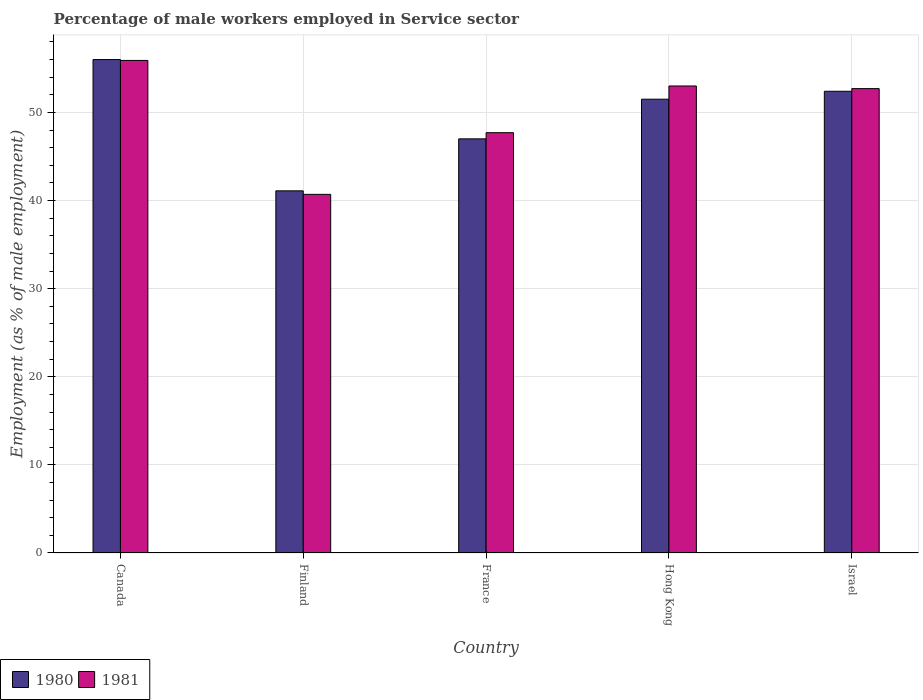How many different coloured bars are there?
Provide a succinct answer. 2. How many groups of bars are there?
Ensure brevity in your answer.  5. What is the label of the 4th group of bars from the left?
Provide a succinct answer. Hong Kong. In how many cases, is the number of bars for a given country not equal to the number of legend labels?
Offer a terse response. 0. Across all countries, what is the maximum percentage of male workers employed in Service sector in 1980?
Your answer should be very brief. 56. Across all countries, what is the minimum percentage of male workers employed in Service sector in 1980?
Keep it short and to the point. 41.1. In which country was the percentage of male workers employed in Service sector in 1980 maximum?
Your answer should be very brief. Canada. In which country was the percentage of male workers employed in Service sector in 1981 minimum?
Your answer should be very brief. Finland. What is the total percentage of male workers employed in Service sector in 1980 in the graph?
Your response must be concise. 248. What is the difference between the percentage of male workers employed in Service sector in 1980 in Canada and that in Israel?
Provide a short and direct response. 3.6. What is the difference between the percentage of male workers employed in Service sector in 1981 in France and the percentage of male workers employed in Service sector in 1980 in Israel?
Your response must be concise. -4.7. What is the average percentage of male workers employed in Service sector in 1980 per country?
Make the answer very short. 49.6. What is the difference between the percentage of male workers employed in Service sector of/in 1981 and percentage of male workers employed in Service sector of/in 1980 in Canada?
Provide a succinct answer. -0.1. What is the ratio of the percentage of male workers employed in Service sector in 1981 in France to that in Israel?
Provide a succinct answer. 0.91. Is the difference between the percentage of male workers employed in Service sector in 1981 in Finland and Israel greater than the difference between the percentage of male workers employed in Service sector in 1980 in Finland and Israel?
Keep it short and to the point. No. What is the difference between the highest and the lowest percentage of male workers employed in Service sector in 1980?
Provide a short and direct response. 14.9. In how many countries, is the percentage of male workers employed in Service sector in 1981 greater than the average percentage of male workers employed in Service sector in 1981 taken over all countries?
Make the answer very short. 3. Is the sum of the percentage of male workers employed in Service sector in 1980 in Finland and Hong Kong greater than the maximum percentage of male workers employed in Service sector in 1981 across all countries?
Provide a succinct answer. Yes. What does the 2nd bar from the left in Canada represents?
Offer a very short reply. 1981. How many bars are there?
Offer a very short reply. 10. Are all the bars in the graph horizontal?
Your answer should be very brief. No. How many countries are there in the graph?
Provide a short and direct response. 5. Are the values on the major ticks of Y-axis written in scientific E-notation?
Your response must be concise. No. Does the graph contain grids?
Your response must be concise. Yes. Where does the legend appear in the graph?
Make the answer very short. Bottom left. What is the title of the graph?
Make the answer very short. Percentage of male workers employed in Service sector. Does "2007" appear as one of the legend labels in the graph?
Make the answer very short. No. What is the label or title of the Y-axis?
Make the answer very short. Employment (as % of male employment). What is the Employment (as % of male employment) in 1980 in Canada?
Your response must be concise. 56. What is the Employment (as % of male employment) of 1981 in Canada?
Provide a short and direct response. 55.9. What is the Employment (as % of male employment) in 1980 in Finland?
Make the answer very short. 41.1. What is the Employment (as % of male employment) of 1981 in Finland?
Make the answer very short. 40.7. What is the Employment (as % of male employment) in 1981 in France?
Keep it short and to the point. 47.7. What is the Employment (as % of male employment) of 1980 in Hong Kong?
Your response must be concise. 51.5. What is the Employment (as % of male employment) of 1981 in Hong Kong?
Your answer should be compact. 53. What is the Employment (as % of male employment) in 1980 in Israel?
Provide a succinct answer. 52.4. What is the Employment (as % of male employment) in 1981 in Israel?
Offer a very short reply. 52.7. Across all countries, what is the maximum Employment (as % of male employment) of 1980?
Give a very brief answer. 56. Across all countries, what is the maximum Employment (as % of male employment) of 1981?
Give a very brief answer. 55.9. Across all countries, what is the minimum Employment (as % of male employment) in 1980?
Offer a very short reply. 41.1. Across all countries, what is the minimum Employment (as % of male employment) of 1981?
Your answer should be very brief. 40.7. What is the total Employment (as % of male employment) in 1980 in the graph?
Ensure brevity in your answer.  248. What is the total Employment (as % of male employment) in 1981 in the graph?
Make the answer very short. 250. What is the difference between the Employment (as % of male employment) of 1981 in Canada and that in Finland?
Make the answer very short. 15.2. What is the difference between the Employment (as % of male employment) in 1980 in Canada and that in France?
Your answer should be very brief. 9. What is the difference between the Employment (as % of male employment) in 1980 in Canada and that in Hong Kong?
Provide a succinct answer. 4.5. What is the difference between the Employment (as % of male employment) of 1981 in Finland and that in France?
Your answer should be very brief. -7. What is the difference between the Employment (as % of male employment) in 1981 in Finland and that in Hong Kong?
Make the answer very short. -12.3. What is the difference between the Employment (as % of male employment) in 1980 in Finland and that in Israel?
Offer a very short reply. -11.3. What is the difference between the Employment (as % of male employment) in 1981 in Finland and that in Israel?
Provide a succinct answer. -12. What is the difference between the Employment (as % of male employment) in 1980 in France and that in Hong Kong?
Your response must be concise. -4.5. What is the difference between the Employment (as % of male employment) of 1980 in France and that in Israel?
Ensure brevity in your answer.  -5.4. What is the difference between the Employment (as % of male employment) in 1980 in Hong Kong and that in Israel?
Your answer should be compact. -0.9. What is the difference between the Employment (as % of male employment) in 1980 in Canada and the Employment (as % of male employment) in 1981 in Israel?
Keep it short and to the point. 3.3. What is the difference between the Employment (as % of male employment) in 1980 in Finland and the Employment (as % of male employment) in 1981 in Israel?
Give a very brief answer. -11.6. What is the difference between the Employment (as % of male employment) in 1980 in France and the Employment (as % of male employment) in 1981 in Hong Kong?
Make the answer very short. -6. What is the average Employment (as % of male employment) of 1980 per country?
Keep it short and to the point. 49.6. What is the average Employment (as % of male employment) of 1981 per country?
Provide a succinct answer. 50. What is the difference between the Employment (as % of male employment) of 1980 and Employment (as % of male employment) of 1981 in Canada?
Ensure brevity in your answer.  0.1. What is the difference between the Employment (as % of male employment) in 1980 and Employment (as % of male employment) in 1981 in Israel?
Keep it short and to the point. -0.3. What is the ratio of the Employment (as % of male employment) in 1980 in Canada to that in Finland?
Keep it short and to the point. 1.36. What is the ratio of the Employment (as % of male employment) of 1981 in Canada to that in Finland?
Ensure brevity in your answer.  1.37. What is the ratio of the Employment (as % of male employment) in 1980 in Canada to that in France?
Offer a terse response. 1.19. What is the ratio of the Employment (as % of male employment) of 1981 in Canada to that in France?
Provide a succinct answer. 1.17. What is the ratio of the Employment (as % of male employment) of 1980 in Canada to that in Hong Kong?
Provide a short and direct response. 1.09. What is the ratio of the Employment (as % of male employment) of 1981 in Canada to that in Hong Kong?
Your response must be concise. 1.05. What is the ratio of the Employment (as % of male employment) of 1980 in Canada to that in Israel?
Make the answer very short. 1.07. What is the ratio of the Employment (as % of male employment) in 1981 in Canada to that in Israel?
Ensure brevity in your answer.  1.06. What is the ratio of the Employment (as % of male employment) in 1980 in Finland to that in France?
Offer a very short reply. 0.87. What is the ratio of the Employment (as % of male employment) in 1981 in Finland to that in France?
Your answer should be compact. 0.85. What is the ratio of the Employment (as % of male employment) of 1980 in Finland to that in Hong Kong?
Give a very brief answer. 0.8. What is the ratio of the Employment (as % of male employment) of 1981 in Finland to that in Hong Kong?
Your answer should be very brief. 0.77. What is the ratio of the Employment (as % of male employment) in 1980 in Finland to that in Israel?
Provide a short and direct response. 0.78. What is the ratio of the Employment (as % of male employment) in 1981 in Finland to that in Israel?
Keep it short and to the point. 0.77. What is the ratio of the Employment (as % of male employment) in 1980 in France to that in Hong Kong?
Your answer should be compact. 0.91. What is the ratio of the Employment (as % of male employment) of 1981 in France to that in Hong Kong?
Keep it short and to the point. 0.9. What is the ratio of the Employment (as % of male employment) in 1980 in France to that in Israel?
Ensure brevity in your answer.  0.9. What is the ratio of the Employment (as % of male employment) of 1981 in France to that in Israel?
Your answer should be very brief. 0.91. What is the ratio of the Employment (as % of male employment) in 1980 in Hong Kong to that in Israel?
Offer a terse response. 0.98. What is the difference between the highest and the second highest Employment (as % of male employment) in 1980?
Provide a short and direct response. 3.6. What is the difference between the highest and the lowest Employment (as % of male employment) in 1980?
Ensure brevity in your answer.  14.9. 